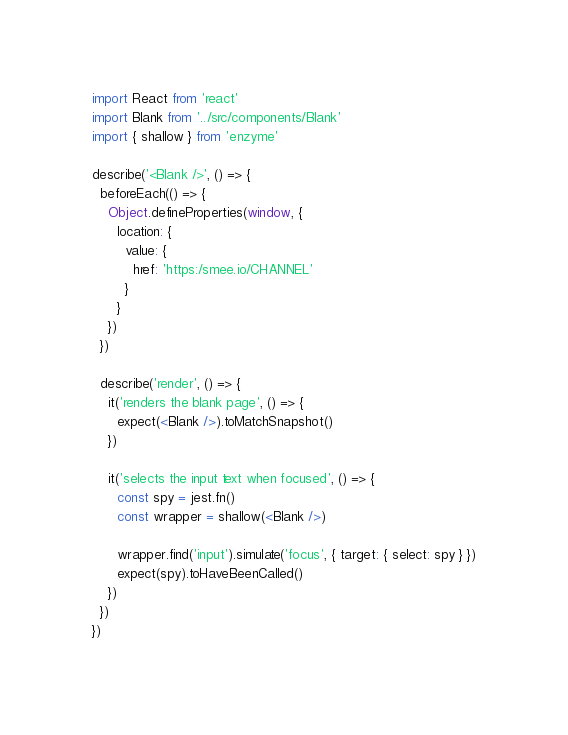Convert code to text. <code><loc_0><loc_0><loc_500><loc_500><_JavaScript_>import React from 'react'
import Blank from '../src/components/Blank'
import { shallow } from 'enzyme'

describe('<Blank />', () => {
  beforeEach(() => {
    Object.defineProperties(window, {
      location: {
        value: {
          href: 'https:/smee.io/CHANNEL'
        }
      }
    })
  })

  describe('render', () => {
    it('renders the blank page', () => {
      expect(<Blank />).toMatchSnapshot()
    })

    it('selects the input text when focused', () => {
      const spy = jest.fn()
      const wrapper = shallow(<Blank />)

      wrapper.find('input').simulate('focus', { target: { select: spy } })
      expect(spy).toHaveBeenCalled()
    })
  })
})
</code> 